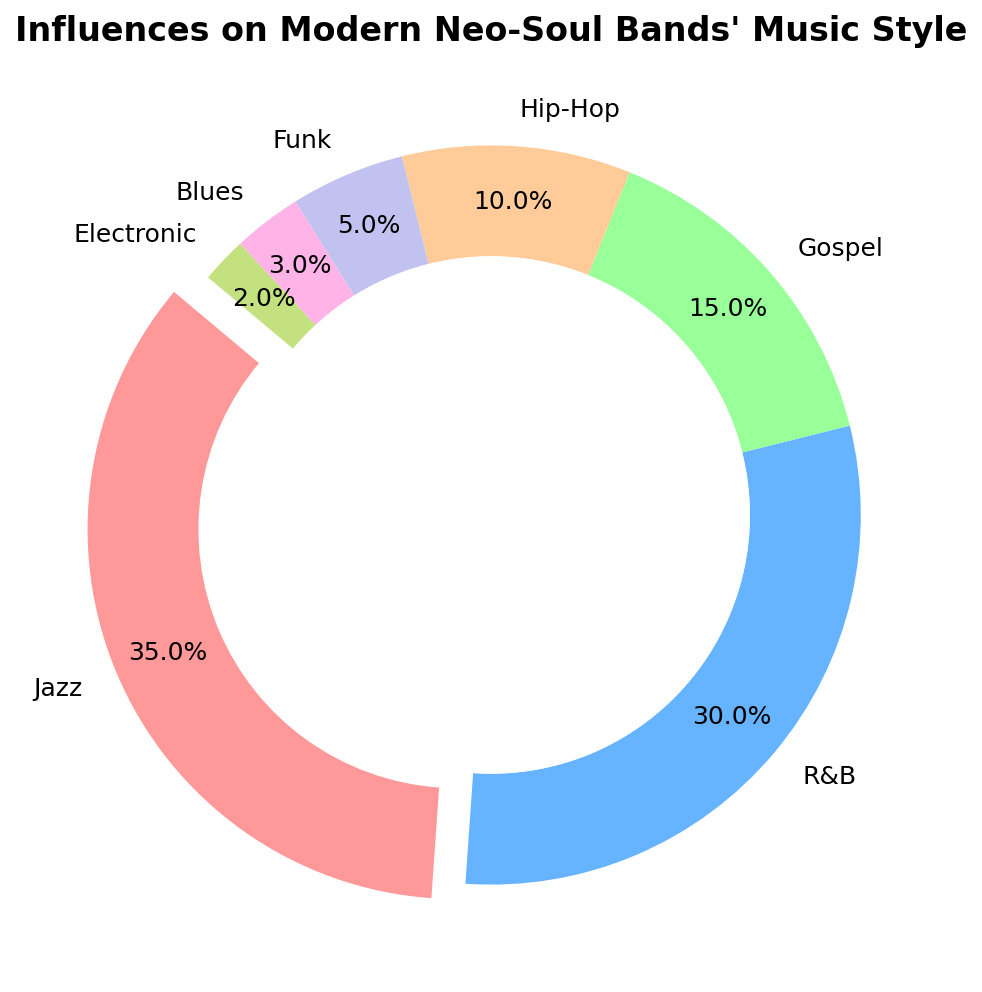What genre has the highest influence on modern neo-soul bands' music style? To determine the genre with the highest influence, look for the largest segment in the chart. The largest segment represents Jazz at 35%.
Answer: Jazz Which genre contributes exactly half of the percentage of Jazz? Jazz contributes 35%, so half of that is 35 / 2 = 17.5%. The only genre with a percentage close to this value is Gospel, which contributes 15%.
Answer: Gospel What's the combined percentage of Funk and Blues influences? Adding the percentages of Funk and Blues results in 5% + 3% = 8%.
Answer: 8% How does the influence of R&B compare to Hip-Hop? Refer to the chart to see the sizes of the segments. R&B is 30%, while Hip-Hop is 10%. Thus, R&B has a greater influence than Hip-Hop by 30% - 10% = 20%.
Answer: R&B has 20% more influence What's the difference in influence between the most and least influential genres? Identify the most influential genre (Jazz at 35%) and the least influential genre (Electronic at 2%) and calculate the difference: 35% - 2% = 33%.
Answer: 33% What colors represent the genres with the two lowest influences and what are the genres? The two smallest segments in the chart are represented by the colors for Blues and Electronic. According to the chart colors, Blues is purple (5th segment) and Electronic is light green (7th segment).
Answer: Purple and light green for Blues and Electronic Is the combined influence of Jazz, R&B, and Gospel more than 75%? Sum the percentages for Jazz, R&B, and Gospel: 35% + 30% + 15% = 80%, which is indeed more than 75%.
Answer: Yes, 80% Which genres have less than 10% influence each? Find segments that represent less than 10% each. These are Hip-Hop (10%), Funk (5%), Blues (3%), and Electronic (2%).
Answer: Funk, Blues, and Electronic What genre, shown in greenish color, has their percentage share in influences? Identify the greenish color segment in the chart. This greenish segment represents Electronic at 2%.
Answer: Electronic at 2% 